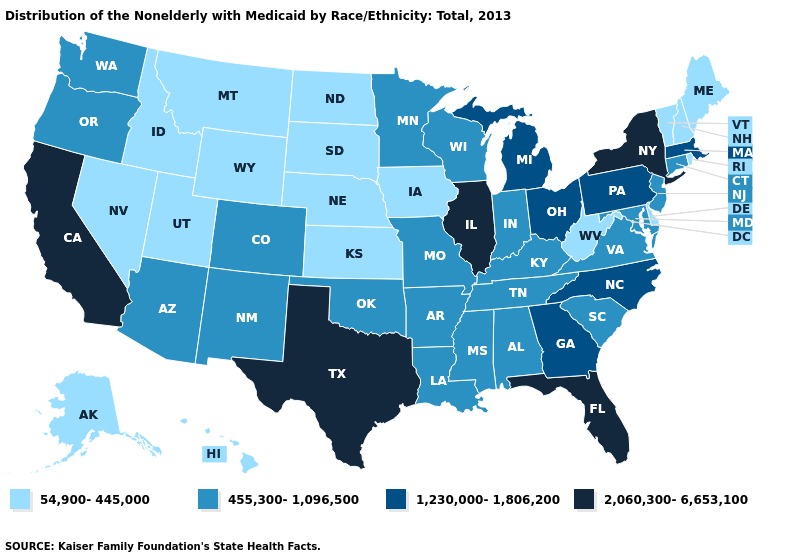What is the value of Arkansas?
Give a very brief answer. 455,300-1,096,500. Does the first symbol in the legend represent the smallest category?
Quick response, please. Yes. Does the map have missing data?
Write a very short answer. No. How many symbols are there in the legend?
Keep it brief. 4. What is the value of North Carolina?
Short answer required. 1,230,000-1,806,200. Among the states that border Utah , does Wyoming have the lowest value?
Quick response, please. Yes. Name the states that have a value in the range 2,060,300-6,653,100?
Be succinct. California, Florida, Illinois, New York, Texas. What is the value of Mississippi?
Be succinct. 455,300-1,096,500. What is the value of Massachusetts?
Short answer required. 1,230,000-1,806,200. Name the states that have a value in the range 1,230,000-1,806,200?
Short answer required. Georgia, Massachusetts, Michigan, North Carolina, Ohio, Pennsylvania. Name the states that have a value in the range 54,900-445,000?
Quick response, please. Alaska, Delaware, Hawaii, Idaho, Iowa, Kansas, Maine, Montana, Nebraska, Nevada, New Hampshire, North Dakota, Rhode Island, South Dakota, Utah, Vermont, West Virginia, Wyoming. Does the first symbol in the legend represent the smallest category?
Quick response, please. Yes. Which states have the lowest value in the USA?
Give a very brief answer. Alaska, Delaware, Hawaii, Idaho, Iowa, Kansas, Maine, Montana, Nebraska, Nevada, New Hampshire, North Dakota, Rhode Island, South Dakota, Utah, Vermont, West Virginia, Wyoming. Which states have the lowest value in the Northeast?
Keep it brief. Maine, New Hampshire, Rhode Island, Vermont. Which states have the highest value in the USA?
Be succinct. California, Florida, Illinois, New York, Texas. 